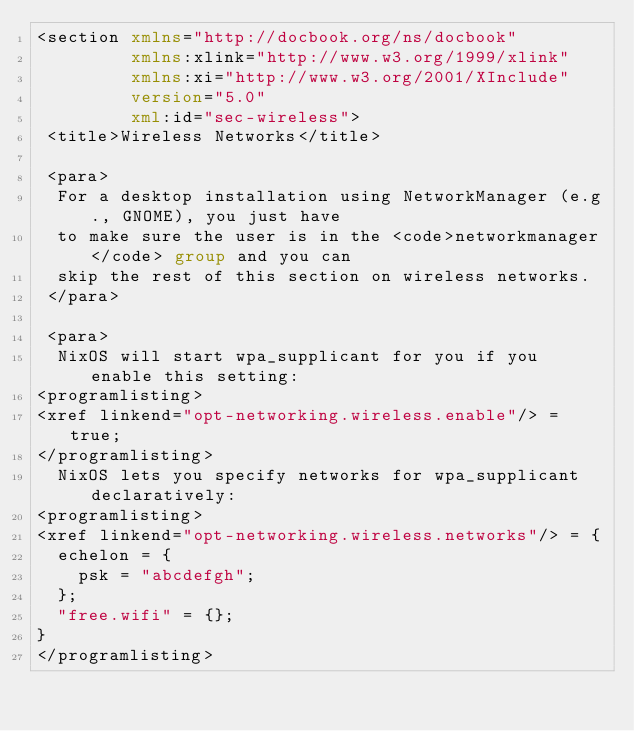Convert code to text. <code><loc_0><loc_0><loc_500><loc_500><_XML_><section xmlns="http://docbook.org/ns/docbook"
         xmlns:xlink="http://www.w3.org/1999/xlink"
         xmlns:xi="http://www.w3.org/2001/XInclude"
         version="5.0"
         xml:id="sec-wireless">
 <title>Wireless Networks</title>

 <para>
  For a desktop installation using NetworkManager (e.g., GNOME), you just have
  to make sure the user is in the <code>networkmanager</code> group and you can
  skip the rest of this section on wireless networks.
 </para>

 <para>
  NixOS will start wpa_supplicant for you if you enable this setting:
<programlisting>
<xref linkend="opt-networking.wireless.enable"/> = true;
</programlisting>
  NixOS lets you specify networks for wpa_supplicant declaratively:
<programlisting>
<xref linkend="opt-networking.wireless.networks"/> = {
  echelon = {
    psk = "abcdefgh";
  };
  "free.wifi" = {};
}
</programlisting></code> 